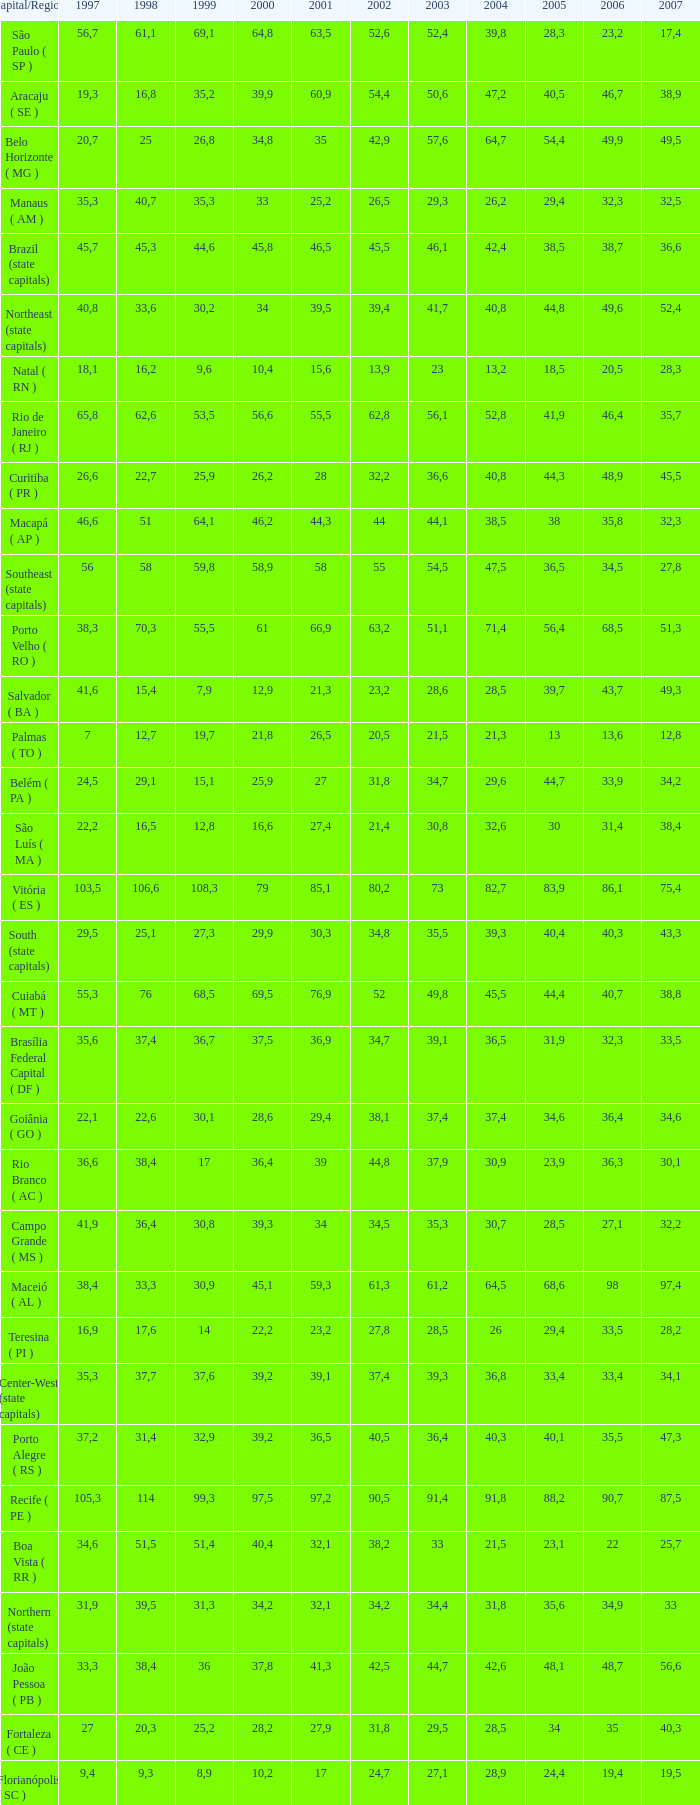How many 2007's have a 2003 less than 36,4, 27,9 as a 2001, and a 1999 less than 25,2? None. 